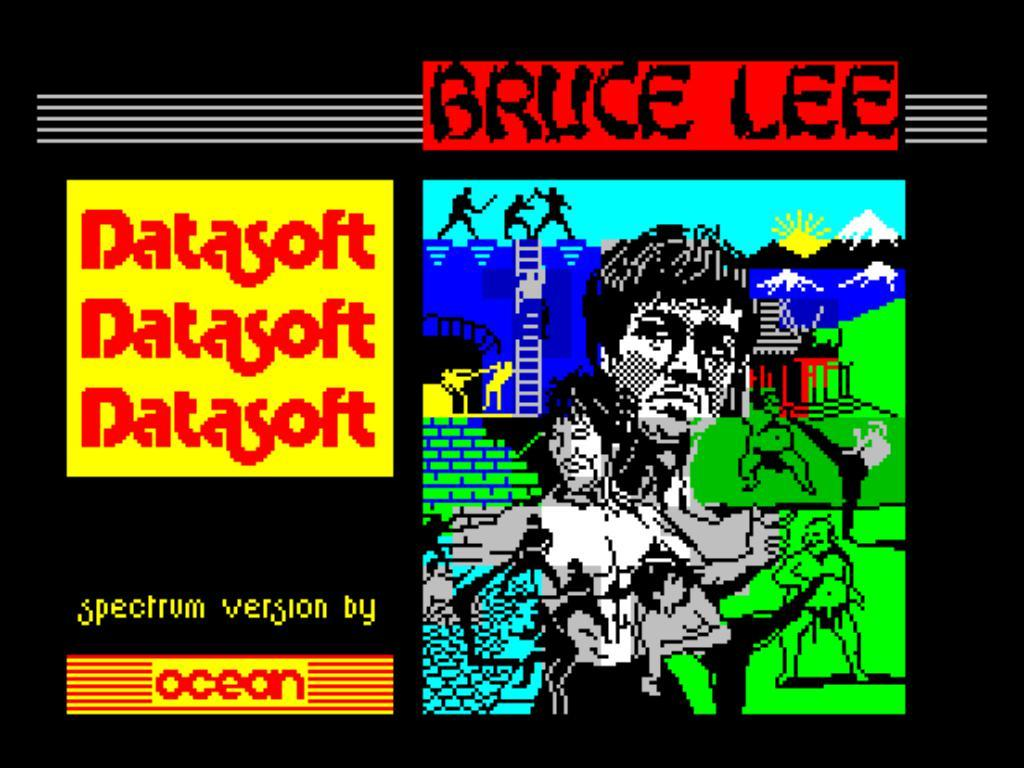<image>
Give a short and clear explanation of the subsequent image. Bruce Lee is available in the spectrum version by Ocean. 